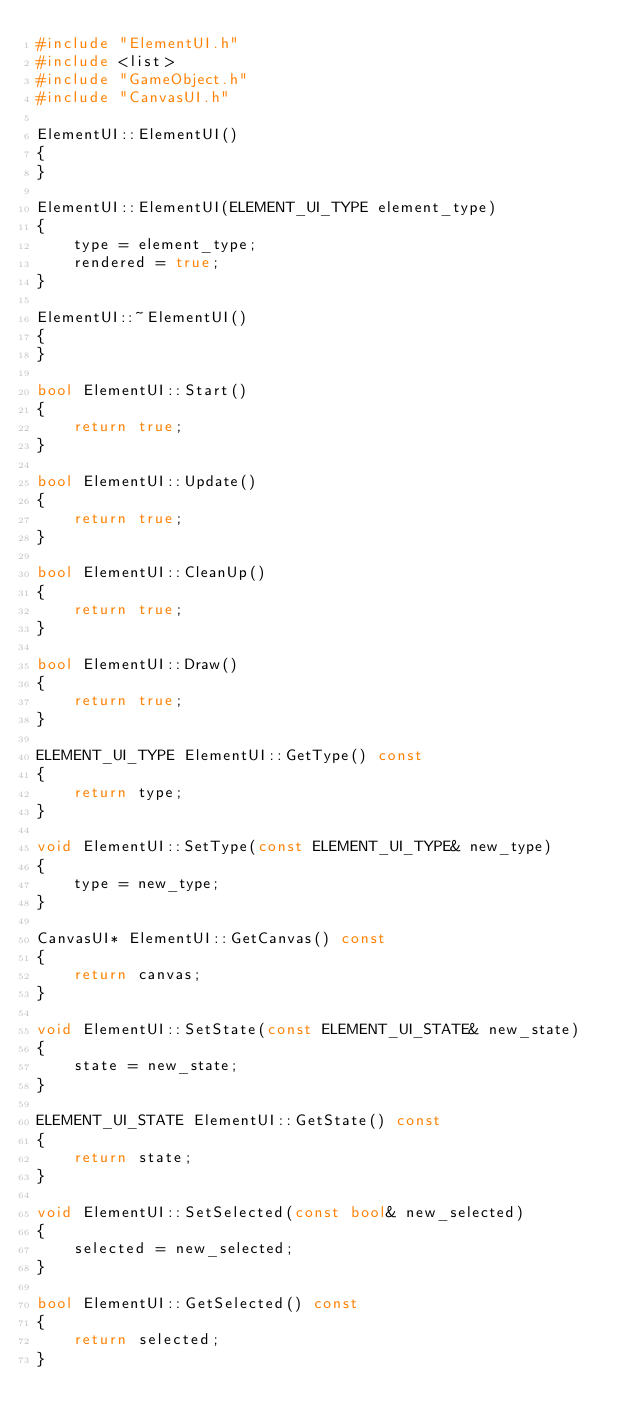Convert code to text. <code><loc_0><loc_0><loc_500><loc_500><_C++_>#include "ElementUI.h"
#include <list>
#include "GameObject.h"
#include "CanvasUI.h"

ElementUI::ElementUI()
{
}

ElementUI::ElementUI(ELEMENT_UI_TYPE element_type)
{
	type = element_type;
	rendered = true;
}

ElementUI::~ElementUI()
{
}

bool ElementUI::Start()
{
	return true;
}

bool ElementUI::Update()
{
	return true;
}

bool ElementUI::CleanUp()
{
	return true;
}

bool ElementUI::Draw()
{
	return true;
}

ELEMENT_UI_TYPE ElementUI::GetType() const
{
	return type;
}

void ElementUI::SetType(const ELEMENT_UI_TYPE& new_type)
{
	type = new_type;
}

CanvasUI* ElementUI::GetCanvas() const
{
	return canvas;
}

void ElementUI::SetState(const ELEMENT_UI_STATE& new_state)
{
	state = new_state;
}

ELEMENT_UI_STATE ElementUI::GetState() const
{
	return state;
}

void ElementUI::SetSelected(const bool& new_selected)
{
	selected = new_selected;
}

bool ElementUI::GetSelected() const
{
	return selected;
}
</code> 